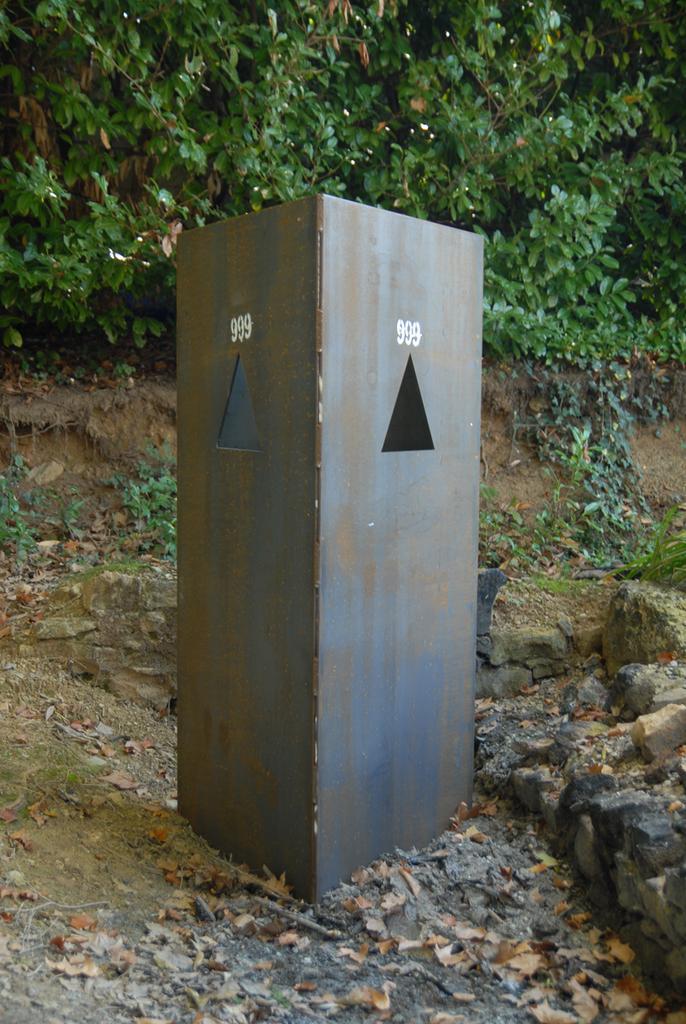How would you summarize this image in a sentence or two? In the image we can see there is an iron box kept on the ground and the ground is covered with dry leaves. Behind there are plants. 